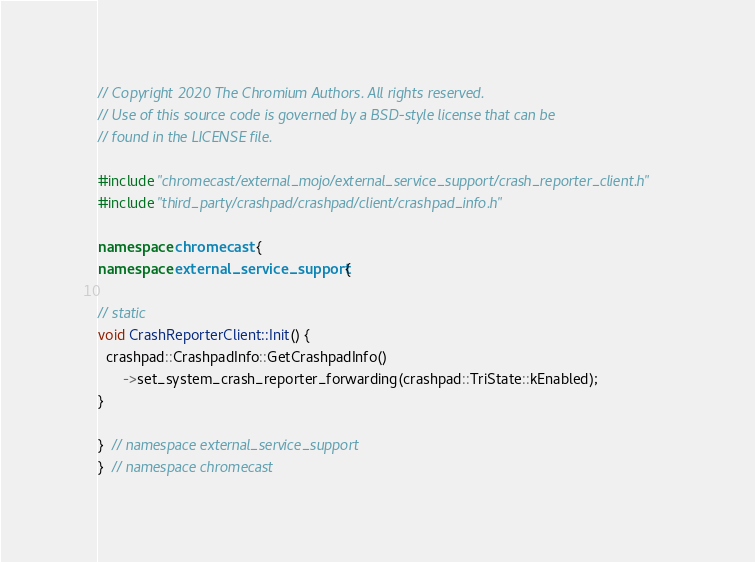Convert code to text. <code><loc_0><loc_0><loc_500><loc_500><_C++_>// Copyright 2020 The Chromium Authors. All rights reserved.
// Use of this source code is governed by a BSD-style license that can be
// found in the LICENSE file.

#include "chromecast/external_mojo/external_service_support/crash_reporter_client.h"
#include "third_party/crashpad/crashpad/client/crashpad_info.h"

namespace chromecast {
namespace external_service_support {

// static
void CrashReporterClient::Init() {
  crashpad::CrashpadInfo::GetCrashpadInfo()
      ->set_system_crash_reporter_forwarding(crashpad::TriState::kEnabled);
}

}  // namespace external_service_support
}  // namespace chromecast
</code> 